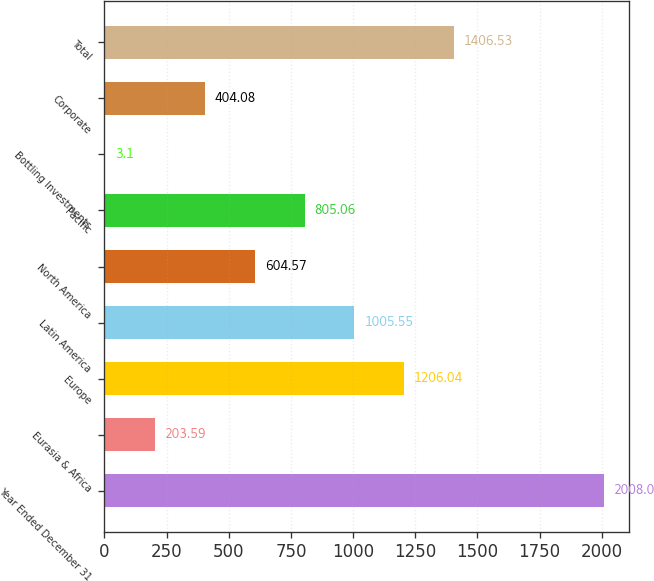Convert chart to OTSL. <chart><loc_0><loc_0><loc_500><loc_500><bar_chart><fcel>Year Ended December 31<fcel>Eurasia & Africa<fcel>Europe<fcel>Latin America<fcel>North America<fcel>Pacific<fcel>Bottling Investments<fcel>Corporate<fcel>Total<nl><fcel>2008<fcel>203.59<fcel>1206.04<fcel>1005.55<fcel>604.57<fcel>805.06<fcel>3.1<fcel>404.08<fcel>1406.53<nl></chart> 